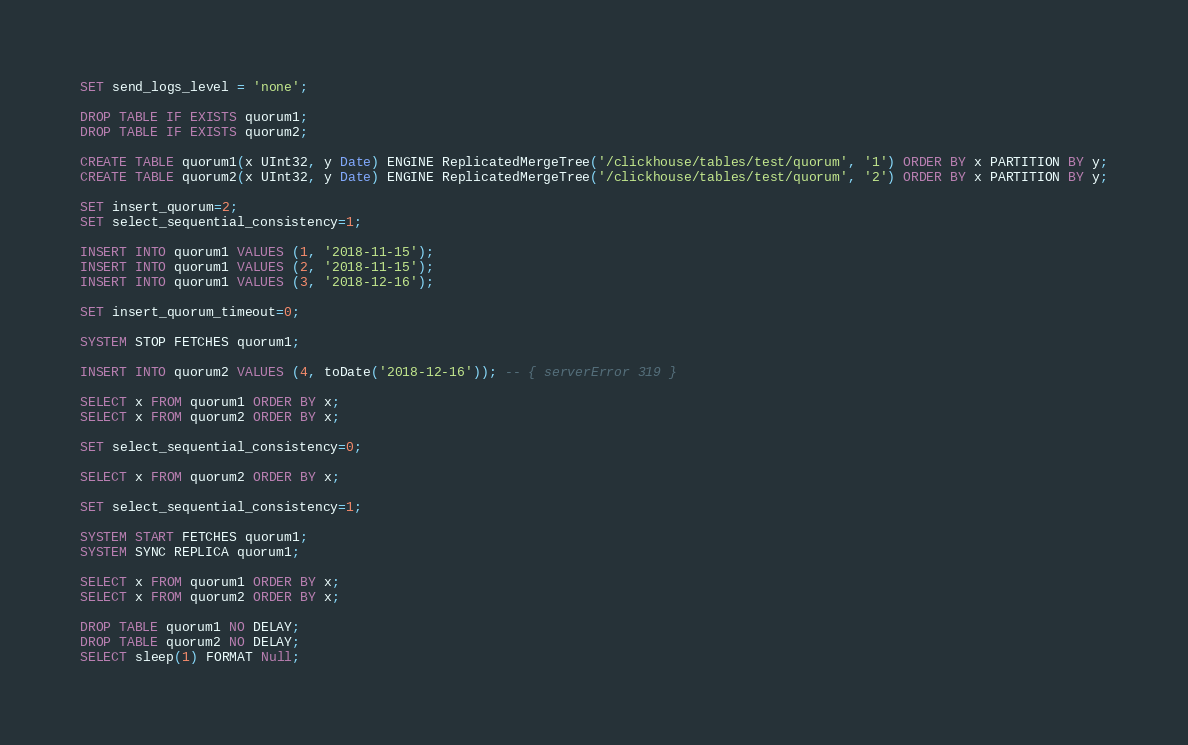<code> <loc_0><loc_0><loc_500><loc_500><_SQL_>SET send_logs_level = 'none';

DROP TABLE IF EXISTS quorum1;
DROP TABLE IF EXISTS quorum2;

CREATE TABLE quorum1(x UInt32, y Date) ENGINE ReplicatedMergeTree('/clickhouse/tables/test/quorum', '1') ORDER BY x PARTITION BY y;
CREATE TABLE quorum2(x UInt32, y Date) ENGINE ReplicatedMergeTree('/clickhouse/tables/test/quorum', '2') ORDER BY x PARTITION BY y;

SET insert_quorum=2;
SET select_sequential_consistency=1;

INSERT INTO quorum1 VALUES (1, '2018-11-15');
INSERT INTO quorum1 VALUES (2, '2018-11-15');
INSERT INTO quorum1 VALUES (3, '2018-12-16');

SET insert_quorum_timeout=0;

SYSTEM STOP FETCHES quorum1;

INSERT INTO quorum2 VALUES (4, toDate('2018-12-16')); -- { serverError 319 }

SELECT x FROM quorum1 ORDER BY x;
SELECT x FROM quorum2 ORDER BY x;

SET select_sequential_consistency=0;

SELECT x FROM quorum2 ORDER BY x;

SET select_sequential_consistency=1;

SYSTEM START FETCHES quorum1;
SYSTEM SYNC REPLICA quorum1;
 
SELECT x FROM quorum1 ORDER BY x;
SELECT x FROM quorum2 ORDER BY x;

DROP TABLE quorum1 NO DELAY;
DROP TABLE quorum2 NO DELAY;
SELECT sleep(1) FORMAT Null;
</code> 